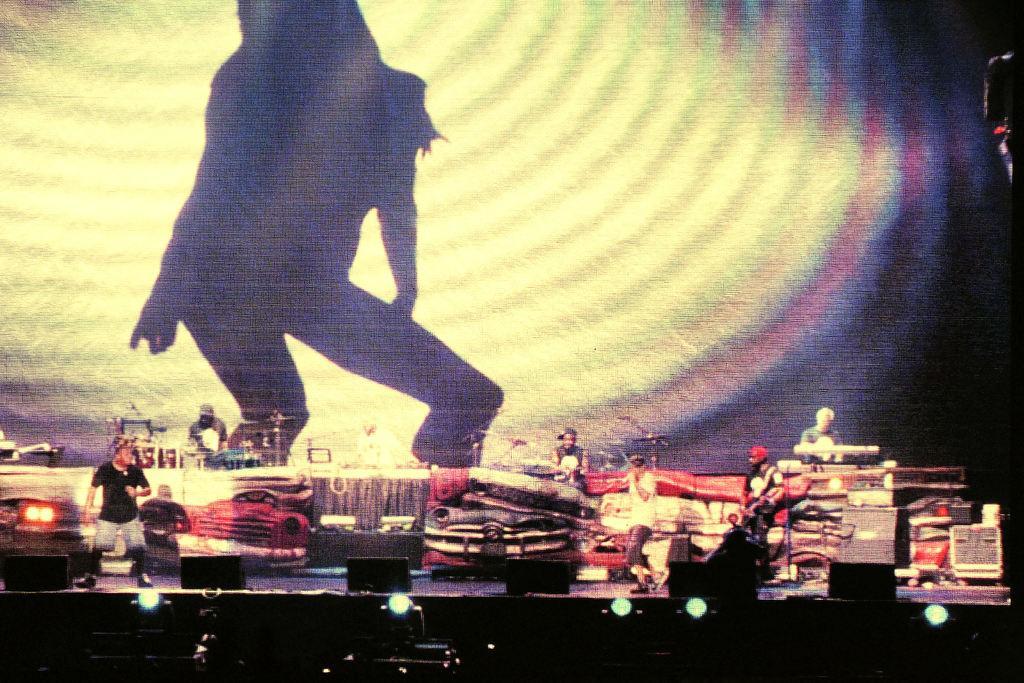Please provide a concise description of this image. In the foreground of the picture there are lights, speakers and other electronic gadgets. In the center of the picture it is stage, on the stage there are people, few are singing a person is playing guitar, other two are playing drums. On the right there is a person playing piano and there are music control system. In the background there is a led screen, on the screen there is a person. 